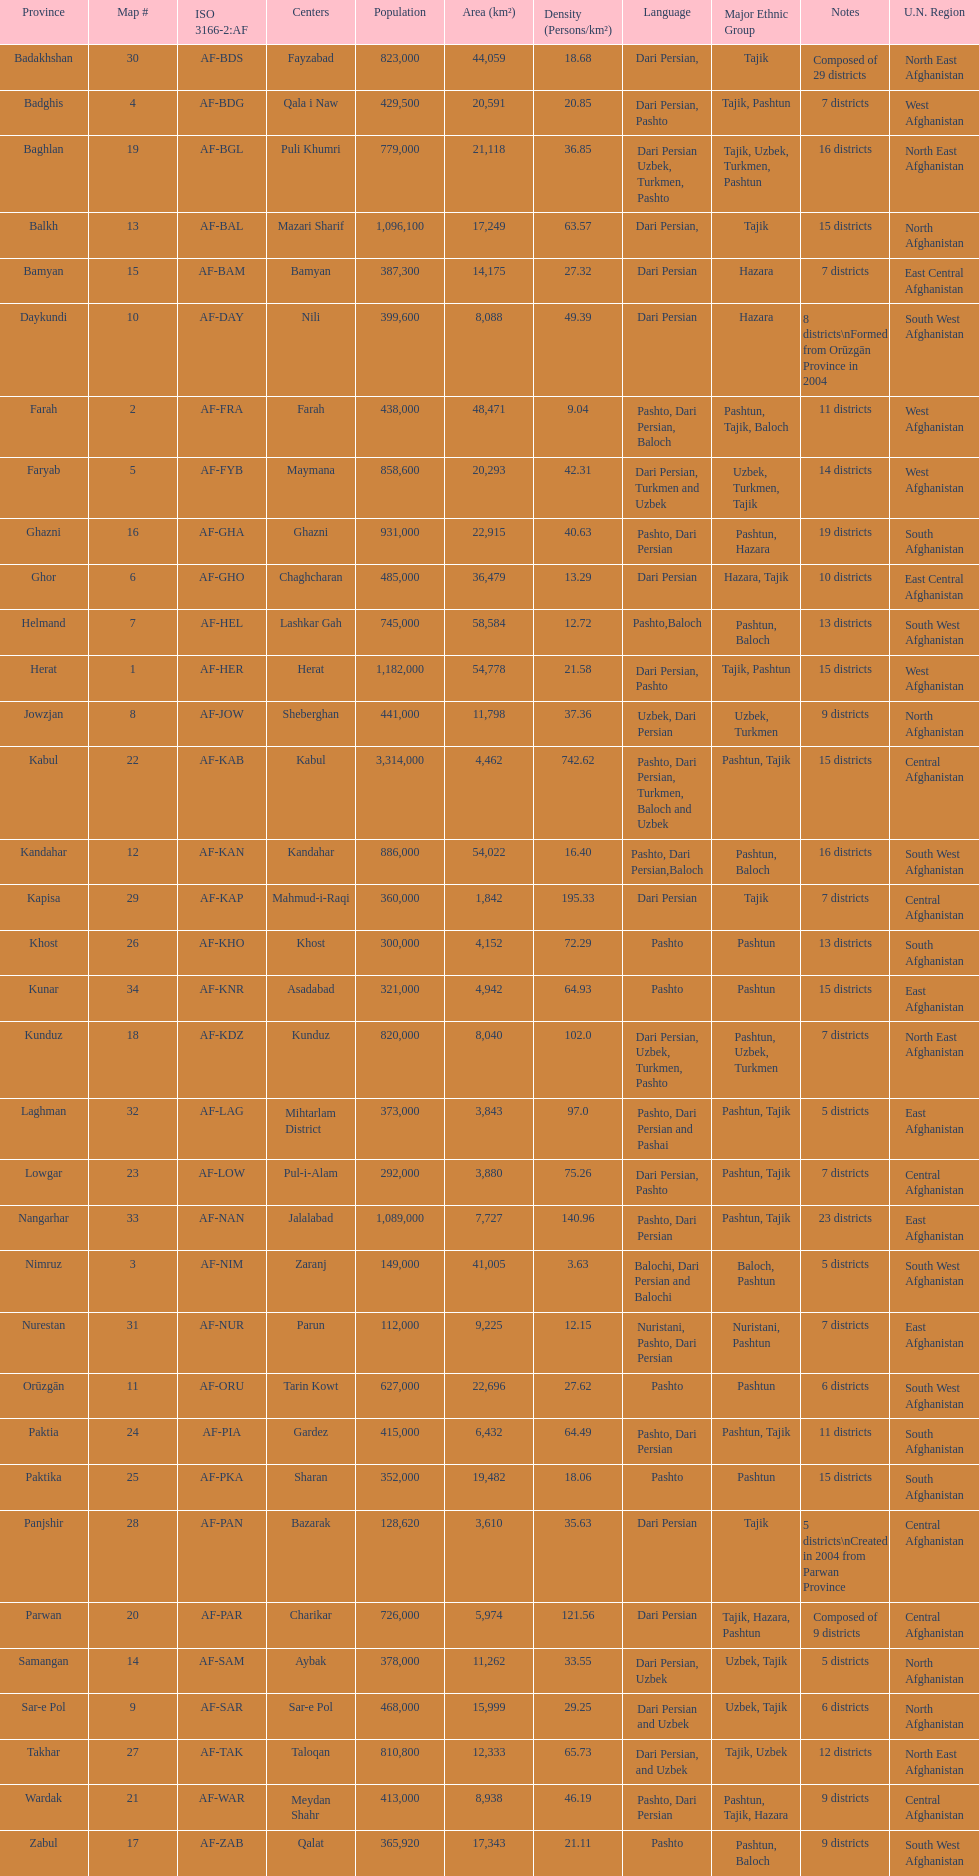Does ghor or farah have more districts? Farah. 